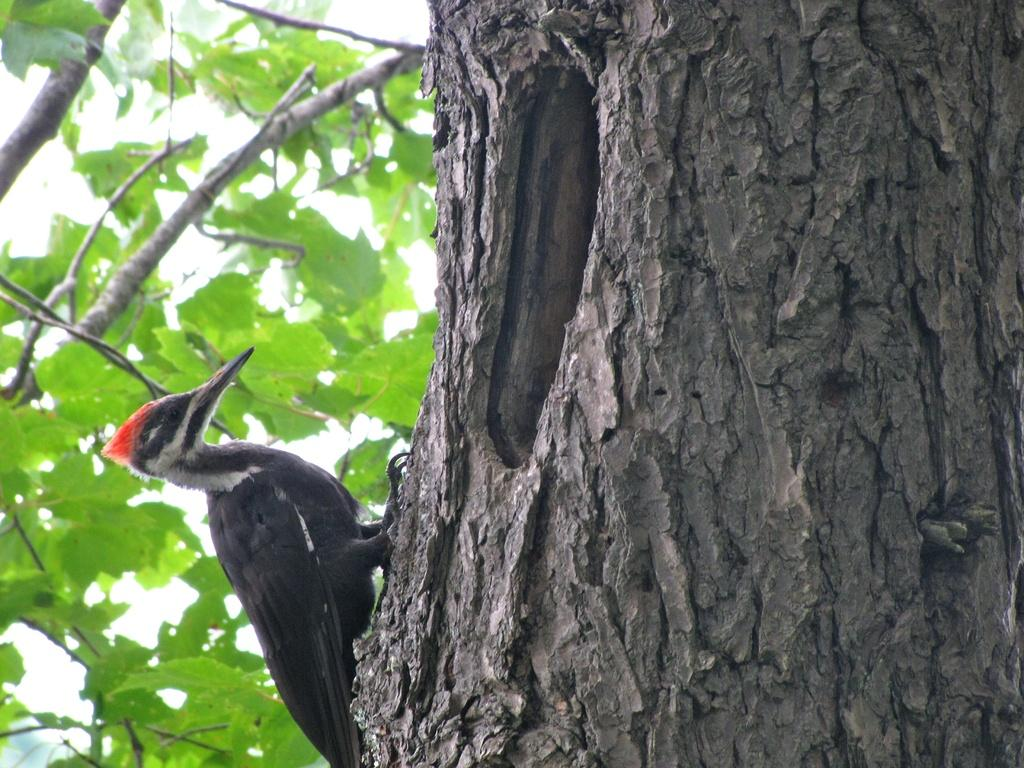What type of bird is in the image? There is a woodpecker in the image. Where is the woodpecker located? The woodpecker is on a tree. What type of fruit is the woodpecker eating in the image? There is no fruit present in the image, and the woodpecker is not shown eating anything. 